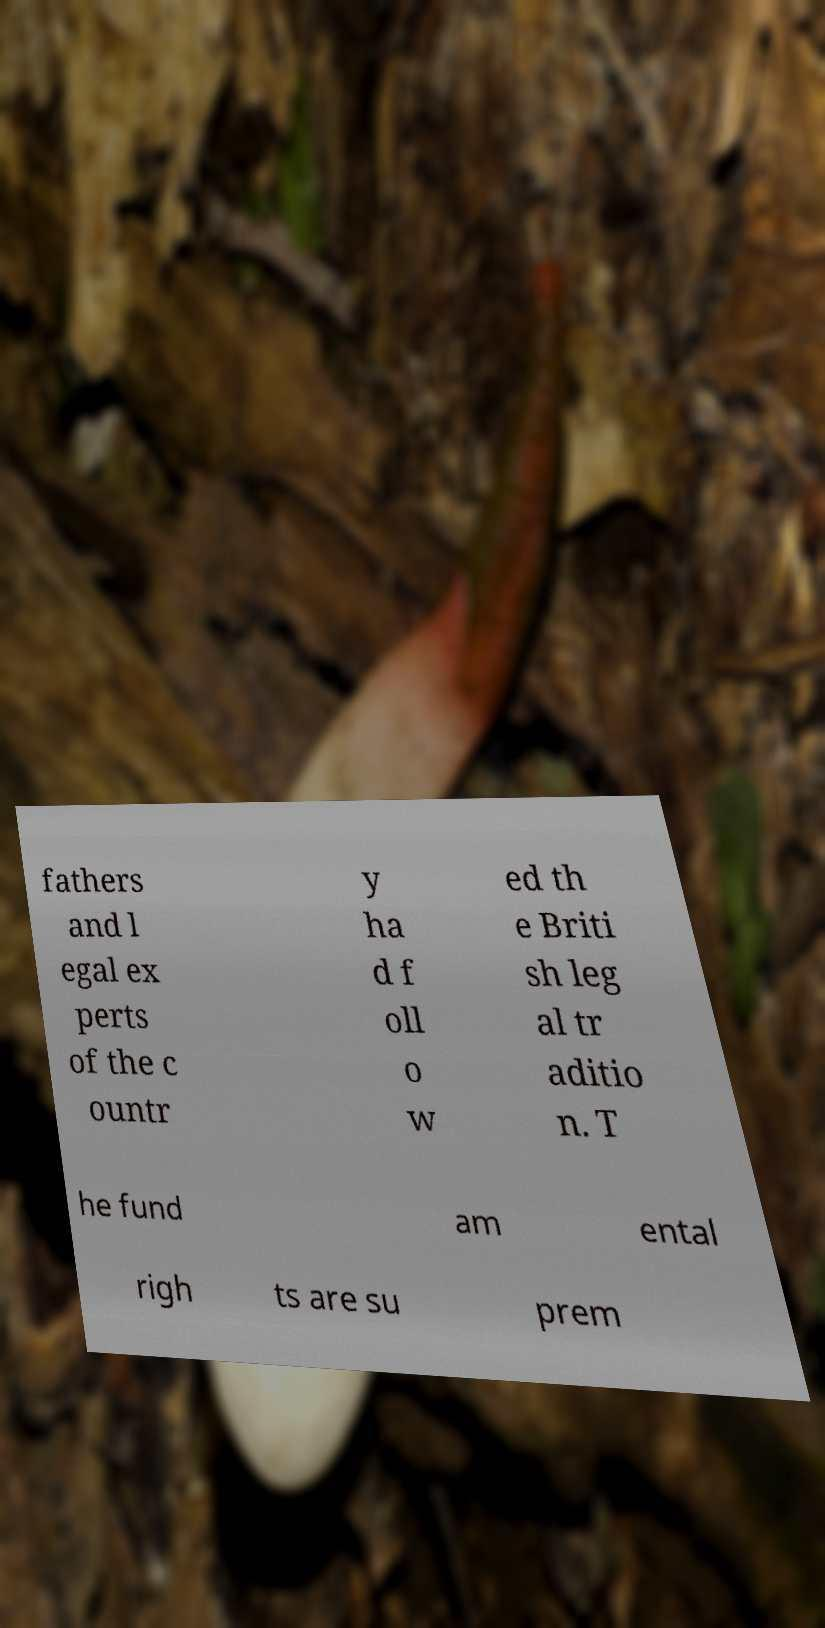I need the written content from this picture converted into text. Can you do that? fathers and l egal ex perts of the c ountr y ha d f oll o w ed th e Briti sh leg al tr aditio n. T he fund am ental righ ts are su prem 